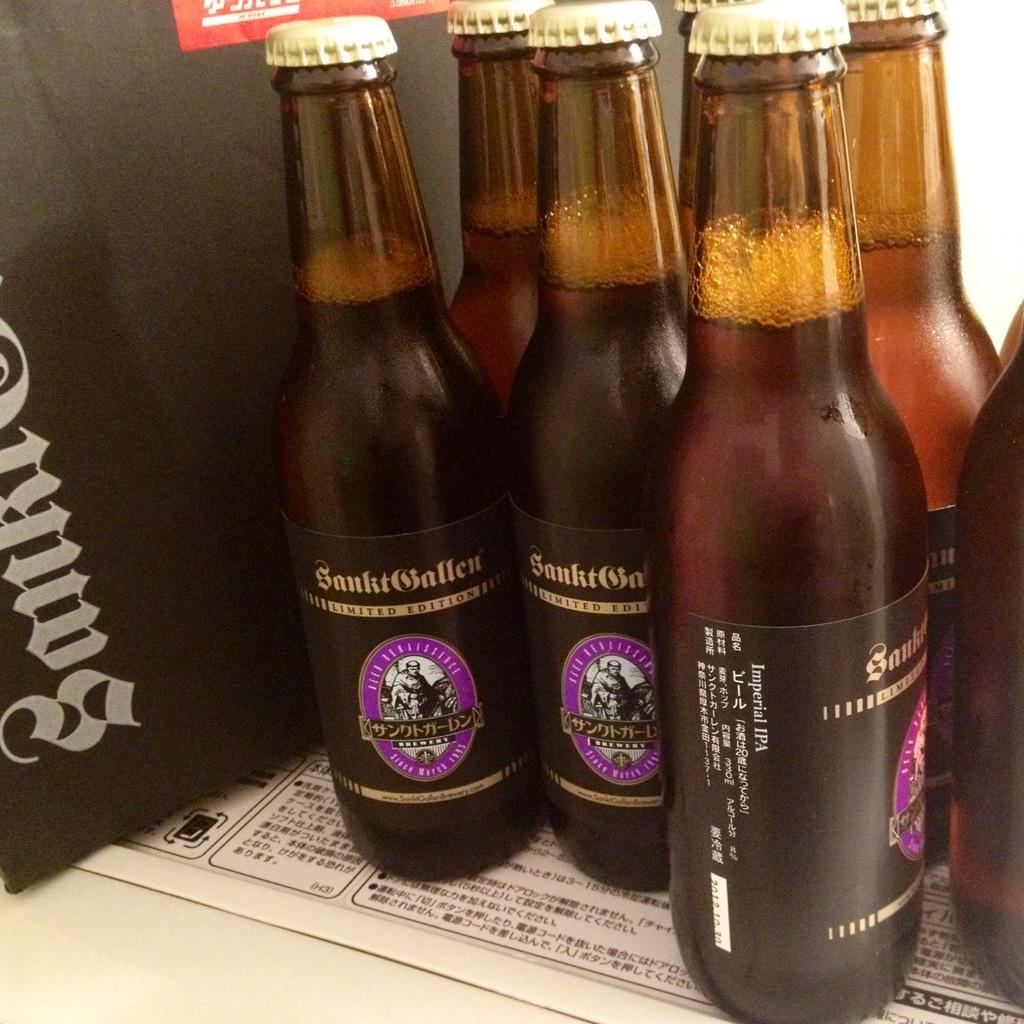What is the name of this beer?
Your answer should be very brief. Unanswerable. Is this limited edition?
Provide a succinct answer. Yes. 